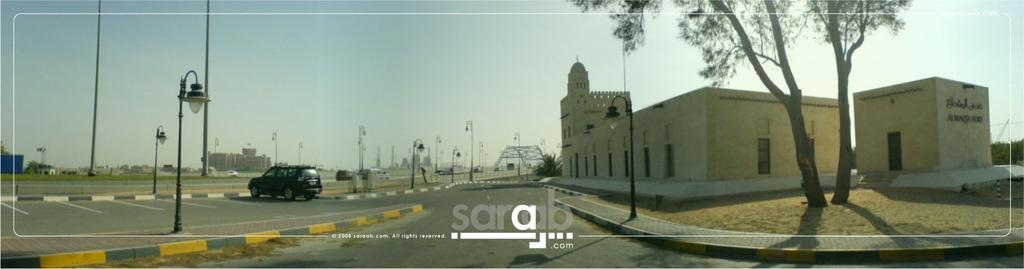Could you give a brief overview of what you see in this image? In this image we can see buildings, tree, street lights, vehicles, road and we can also see the sky. 